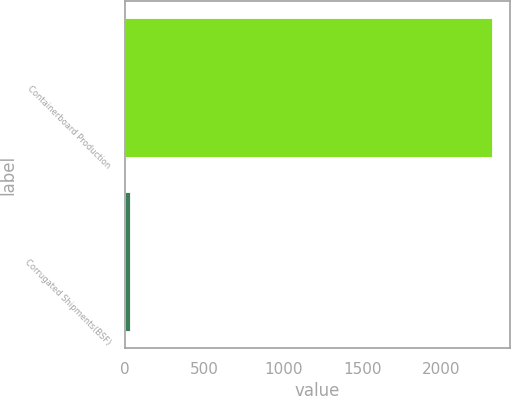<chart> <loc_0><loc_0><loc_500><loc_500><bar_chart><fcel>Containerboard Production<fcel>Corrugated Shipments(BSF)<nl><fcel>2318<fcel>29.9<nl></chart> 